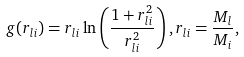Convert formula to latex. <formula><loc_0><loc_0><loc_500><loc_500>g ( r _ { l i } ) = r _ { l i } \ln \left ( \frac { 1 + r ^ { 2 } _ { l i } } { r ^ { 2 } _ { l i } } \right ) , r _ { l i } = \frac { M _ { l } } { M _ { i } } ,</formula> 